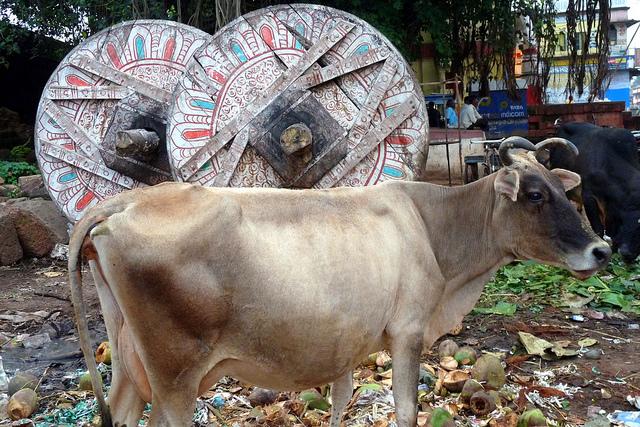Is the goat too hot?
Write a very short answer. No. Is this a cow?
Quick response, please. Yes. What color is the goat?
Answer briefly. Tan. 